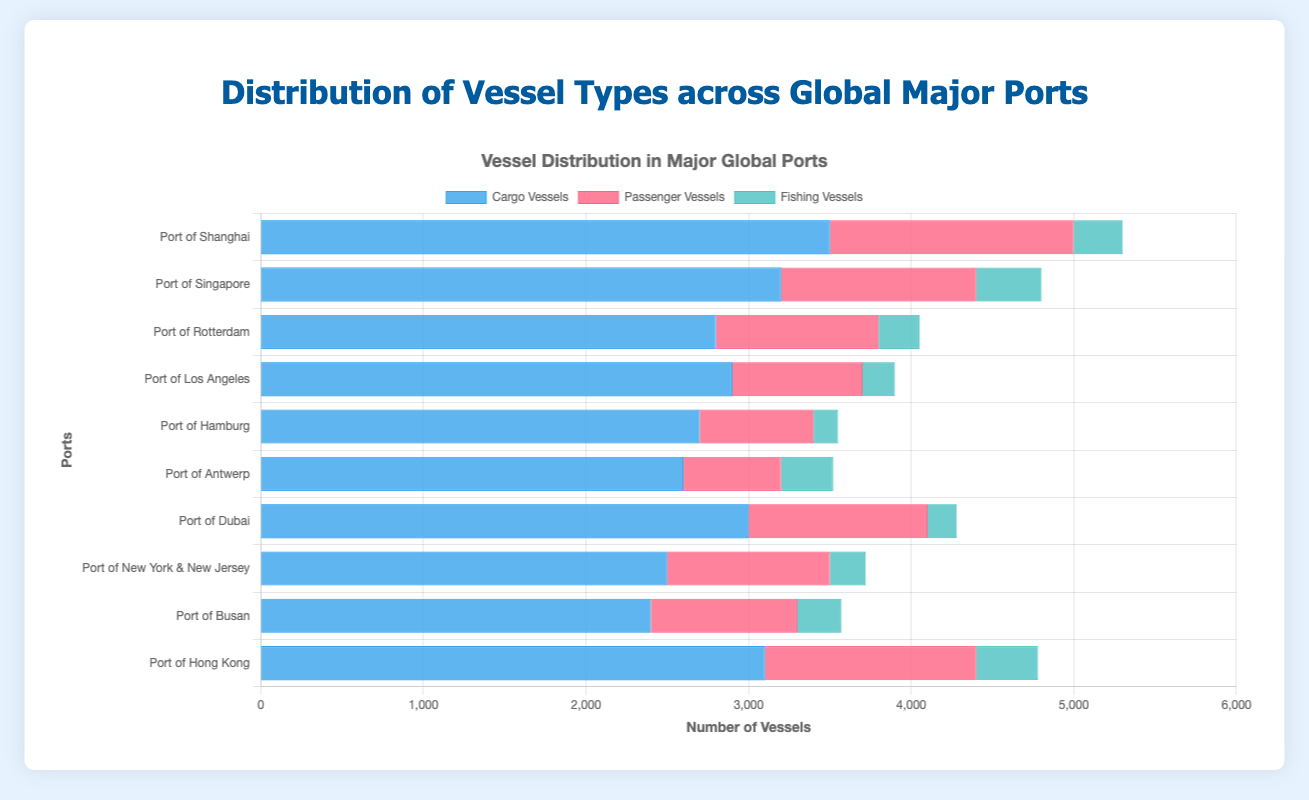Which port has the highest number of cargo vessels? The Port of Shanghai has the highest number of cargo vessels with 3500 vessels.
Answer: Port of Shanghai Which port has the most passenger vessels and how many are there? By comparing the bars for passenger vessels, Port of Shanghai has the most with 1500 vessels.
Answer: Port of Shanghai with 1500 vessels What is the total number of fishing vessels in the Port of Rotterdam and the Port of Busan combined? Add the number of fishing vessels for both ports: 250 (Rotterdam) + 270 (Busan) = 520.
Answer: 520 Among cargo vessels, passenger vessels, and fishing vessels, which type is the most numerous in the Port of Antwerp? By comparing the height of the bars for the Port of Antwerp, cargo vessels are the most numerous with 2600 vessels.
Answer: Cargo vessels Which port has the smallest number of fishing vessels and how many are there? The Port of Hamburg has the smallest number of fishing vessels with 150 vessels.
Answer: Port of Hamburg with 150 vessels Compare the total number of vessels (all types combined) in the Port of Dubai and the Port of Los Angeles. Which port has more vessels and by how many? Calculate the total for each port: Dubai (3000 + 1100 + 180 = 4280) and Los Angeles (2900 + 800 + 200 = 3900). Dubai has 4280 - 3900 = 380 more vessels than Los Angeles.
Answer: Port of Dubai by 380 vessels What is the average number of cargo vessels across all ports? Sum the cargo vessels and divide by the number of ports: (3500 + 3200 + 2800 + 2900 + 2700 + 2600 + 3000 + 2500 + 2400 + 3100) / 10 = 2870.
Answer: 2870 Which port has the second highest number of passenger vessels? Identify the port with the second highest bar after Shanghai. Port of Hong Kong has the second highest number of passenger vessels with 1300.
Answer: Port of Hong Kong How many more cargo vessels are there in the Port of Shanghai compared to the Port of New York & New Jersey? Subtract the number of cargo vessels: 3500 (Shanghai) - 2500 (New York & New Jersey) = 1000.
Answer: 1000 Are there more passenger vessels or cargo vessels in the Port of Singapore? Compare the bars for passenger and cargo vessels in Singapore. There are 3200 cargo vessels and 1200 passenger vessels, so there are more cargo vessels.
Answer: Cargo vessels 